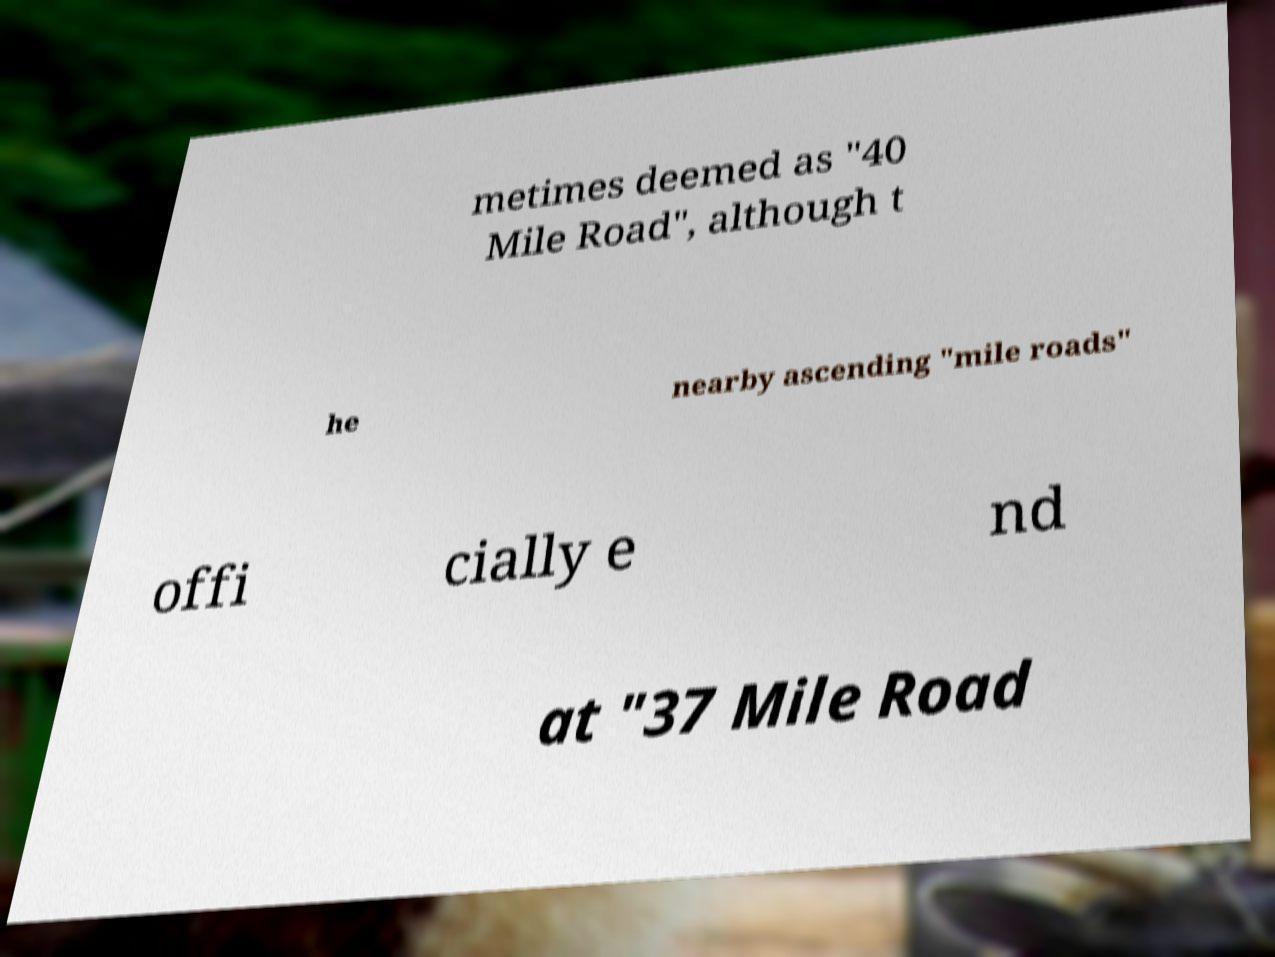Can you read and provide the text displayed in the image?This photo seems to have some interesting text. Can you extract and type it out for me? metimes deemed as "40 Mile Road", although t he nearby ascending "mile roads" offi cially e nd at "37 Mile Road 